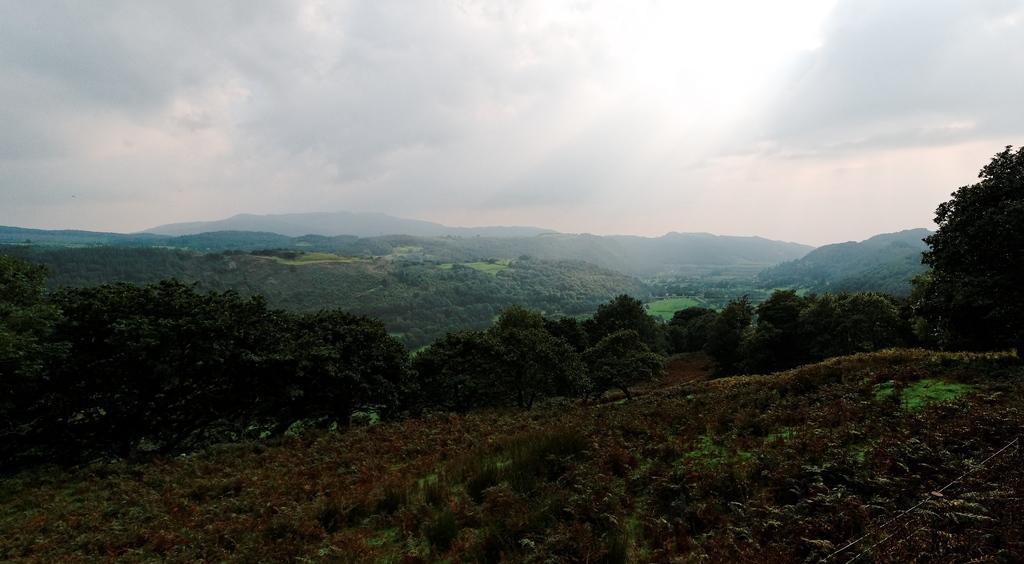Can you describe this image briefly? In this image I can see grass, plants, trees and mountains. At the top I can see the sky. This image is taken may be near the hill station. 